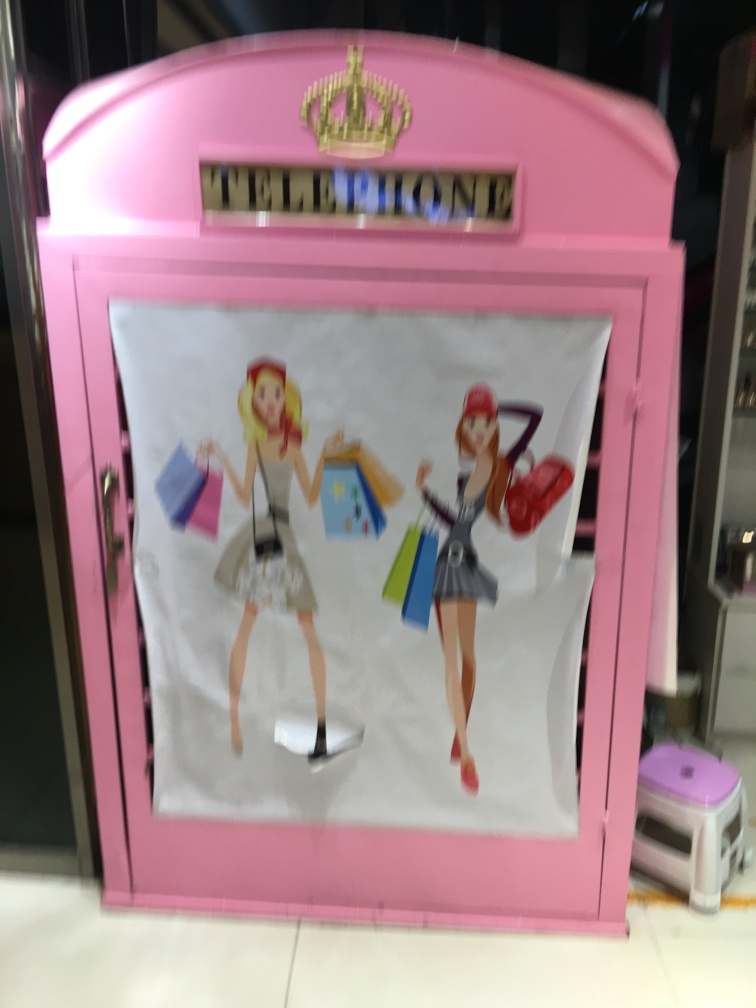Do the illustrations on the telephone booth convey any particular message or theme? The illustrations of two characters with shopping bags suggest a theme related to retail and fashion. It could imply that the phone booth is situated in a shopping mall or a district known for shopping, aiming to resonate with shoppers and the commerce-centric atmosphere. 